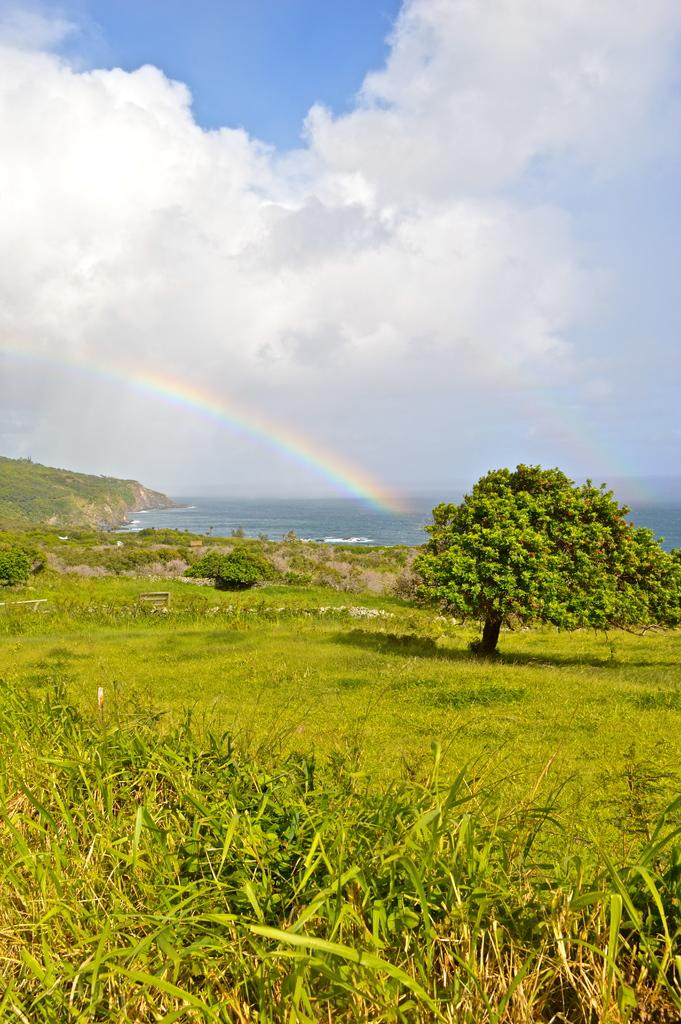What type of landscape is depicted in the image? There is a grassland in the image. Are there any specific features within the grassland? Yes, there is a tree in the grassland. What can be seen in the distance behind the grassland? There is a sea in the background of the image. What is visible above the grassland and sea? There is a sky visible in the image. What additional feature can be seen in the sky? There is a rainbow in the sky. Where is the quiver of arrows located in the image? There is no quiver of arrows present in the image. Can you describe the stream that runs through the grassland in the image? There is no stream running through the grassland in the image. 